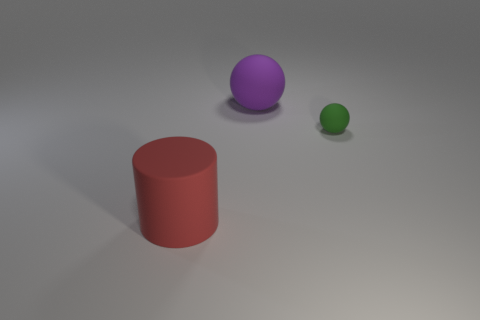Add 2 big purple balls. How many objects exist? 5 Subtract all spheres. How many objects are left? 1 Subtract all large purple spheres. Subtract all large gray balls. How many objects are left? 2 Add 1 large red rubber cylinders. How many large red rubber cylinders are left? 2 Add 2 blue cylinders. How many blue cylinders exist? 2 Subtract 0 green blocks. How many objects are left? 3 